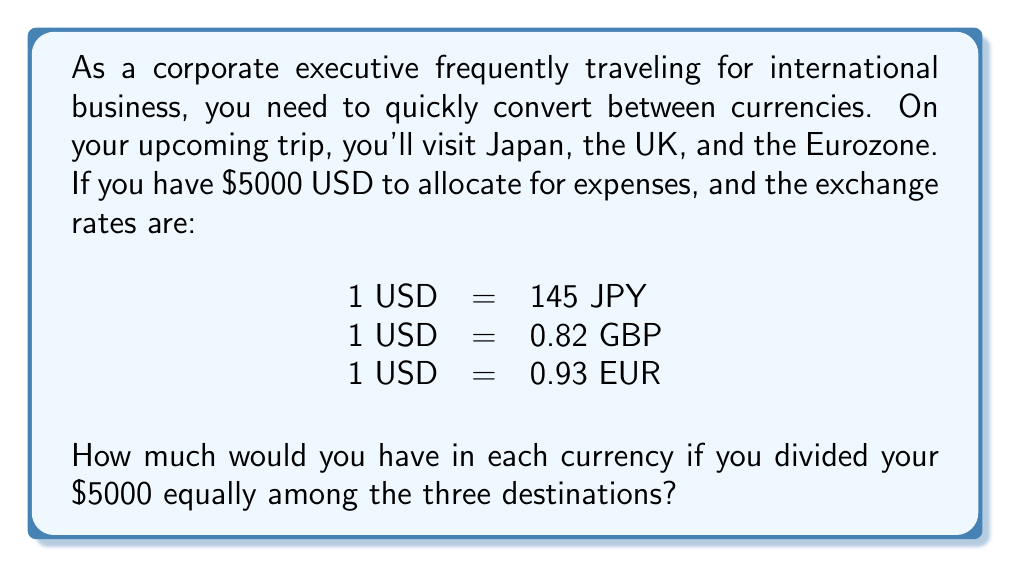Can you solve this math problem? To solve this problem, we'll follow these steps:

1. Divide the total amount equally among the three destinations:
   $$\frac{$5000}{3} = $1666.67$$ (rounded to two decimal places)

2. Convert $1666.67 to each currency using the given exchange rates:

   For Japanese Yen (JPY):
   $$1666.67 \times 145 = 241,667.15 \text{ JPY}$$

   For British Pounds (GBP):
   $$1666.67 \times 0.82 = 1,366.67 \text{ GBP}$$

   For Euros (EUR):
   $$1666.67 \times 0.93 = 1,550.00 \text{ EUR}$$

3. Round each result to the nearest whole unit of currency, as fractional units are not typically used in cash transactions:

   JPY: 241,667 (rounded down)
   GBP: 1,367 (rounded up)
   EUR: 1,550 (already whole)
Answer: 241,667 JPY, 1,367 GBP, 1,550 EUR 